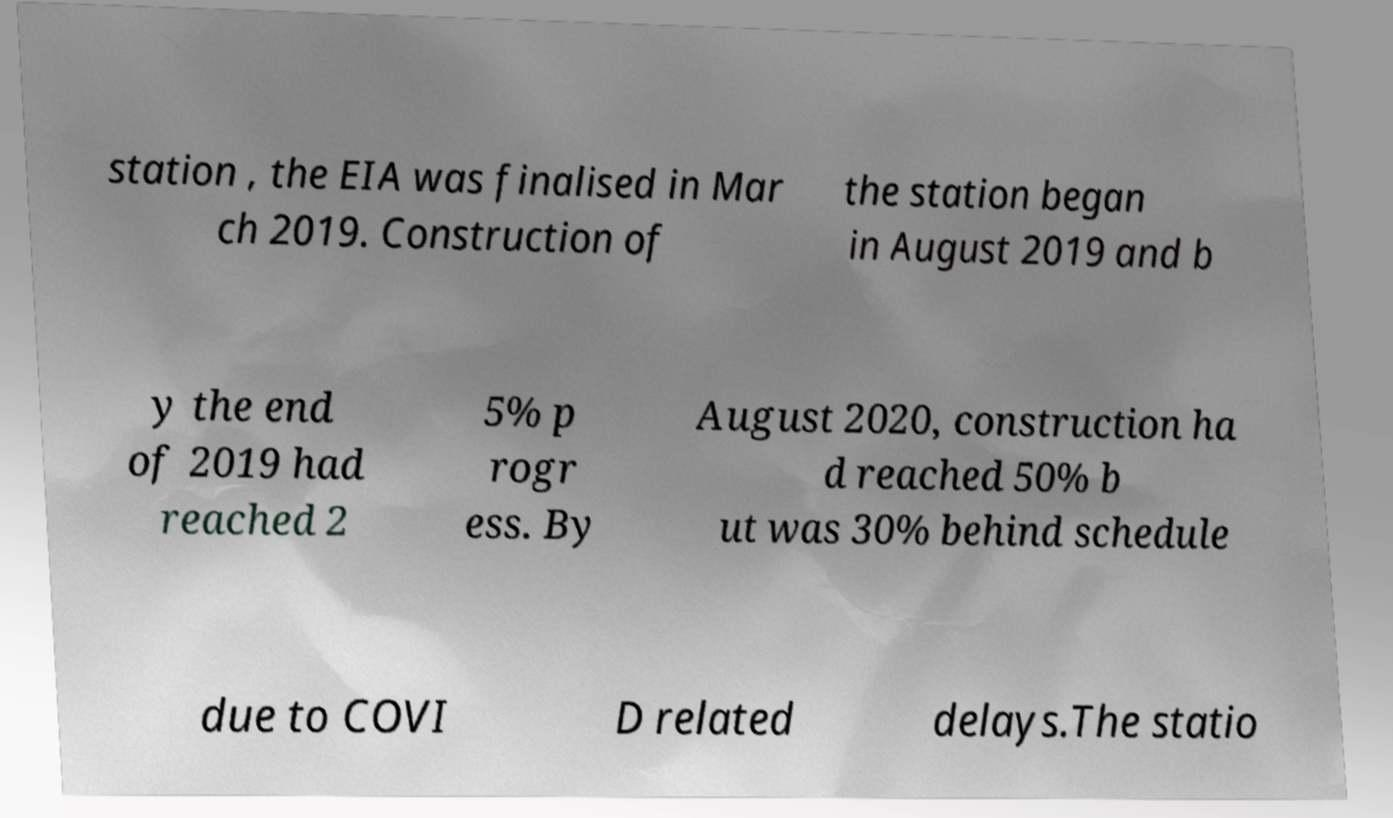Please identify and transcribe the text found in this image. station , the EIA was finalised in Mar ch 2019. Construction of the station began in August 2019 and b y the end of 2019 had reached 2 5% p rogr ess. By August 2020, construction ha d reached 50% b ut was 30% behind schedule due to COVI D related delays.The statio 